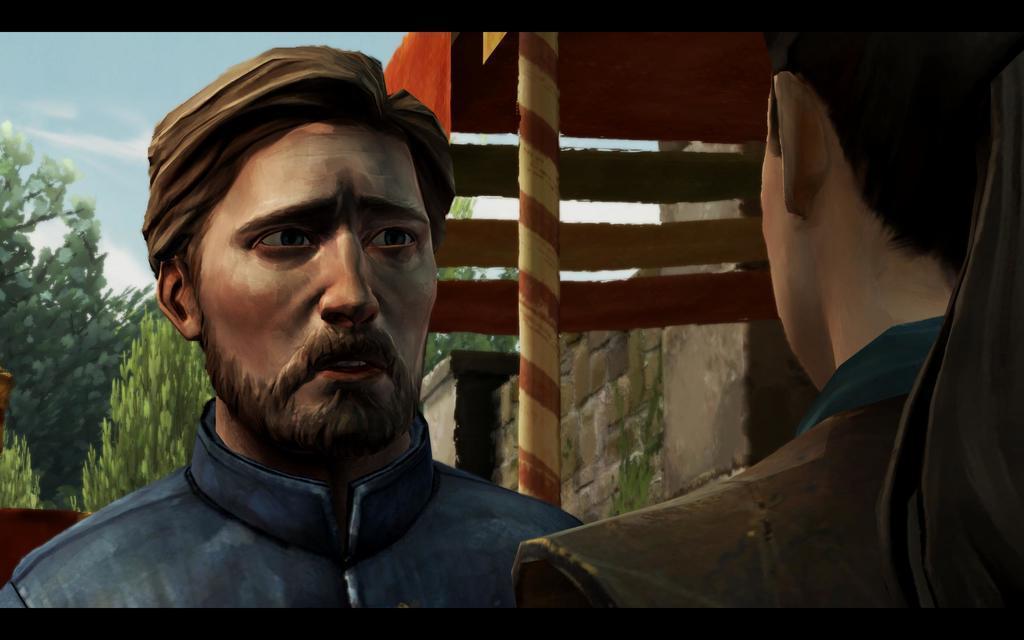In one or two sentences, can you explain what this image depicts? This is an animated image. In the image on the right side there is a person. And on the left side there is a man. Behind them there is a pole. And also there are trees and walls. 